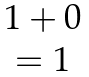Convert formula to latex. <formula><loc_0><loc_0><loc_500><loc_500>\begin{matrix} 1 + 0 \\ = { 1 } \end{matrix}</formula> 